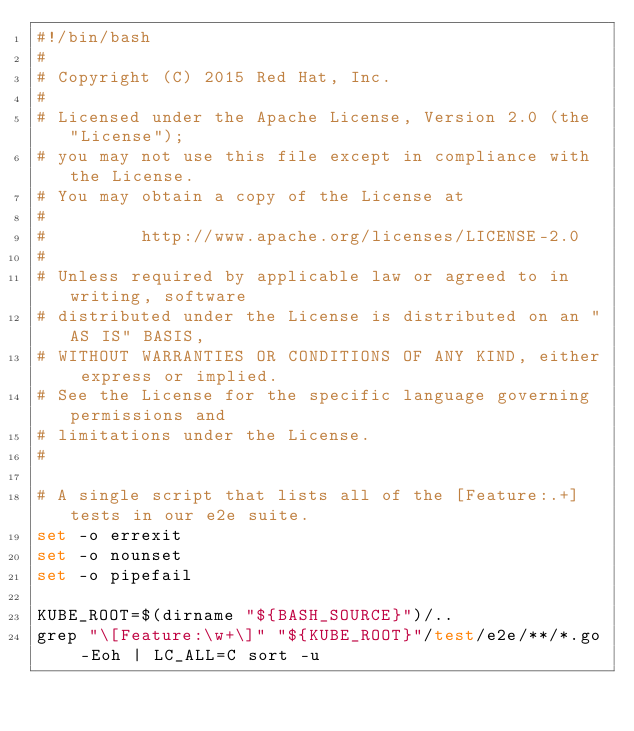<code> <loc_0><loc_0><loc_500><loc_500><_Bash_>#!/bin/bash
#
# Copyright (C) 2015 Red Hat, Inc.
#
# Licensed under the Apache License, Version 2.0 (the "License");
# you may not use this file except in compliance with the License.
# You may obtain a copy of the License at
#
#         http://www.apache.org/licenses/LICENSE-2.0
#
# Unless required by applicable law or agreed to in writing, software
# distributed under the License is distributed on an "AS IS" BASIS,
# WITHOUT WARRANTIES OR CONDITIONS OF ANY KIND, either express or implied.
# See the License for the specific language governing permissions and
# limitations under the License.
#

# A single script that lists all of the [Feature:.+] tests in our e2e suite.
set -o errexit
set -o nounset
set -o pipefail

KUBE_ROOT=$(dirname "${BASH_SOURCE}")/..
grep "\[Feature:\w+\]" "${KUBE_ROOT}"/test/e2e/**/*.go -Eoh | LC_ALL=C sort -u
</code> 